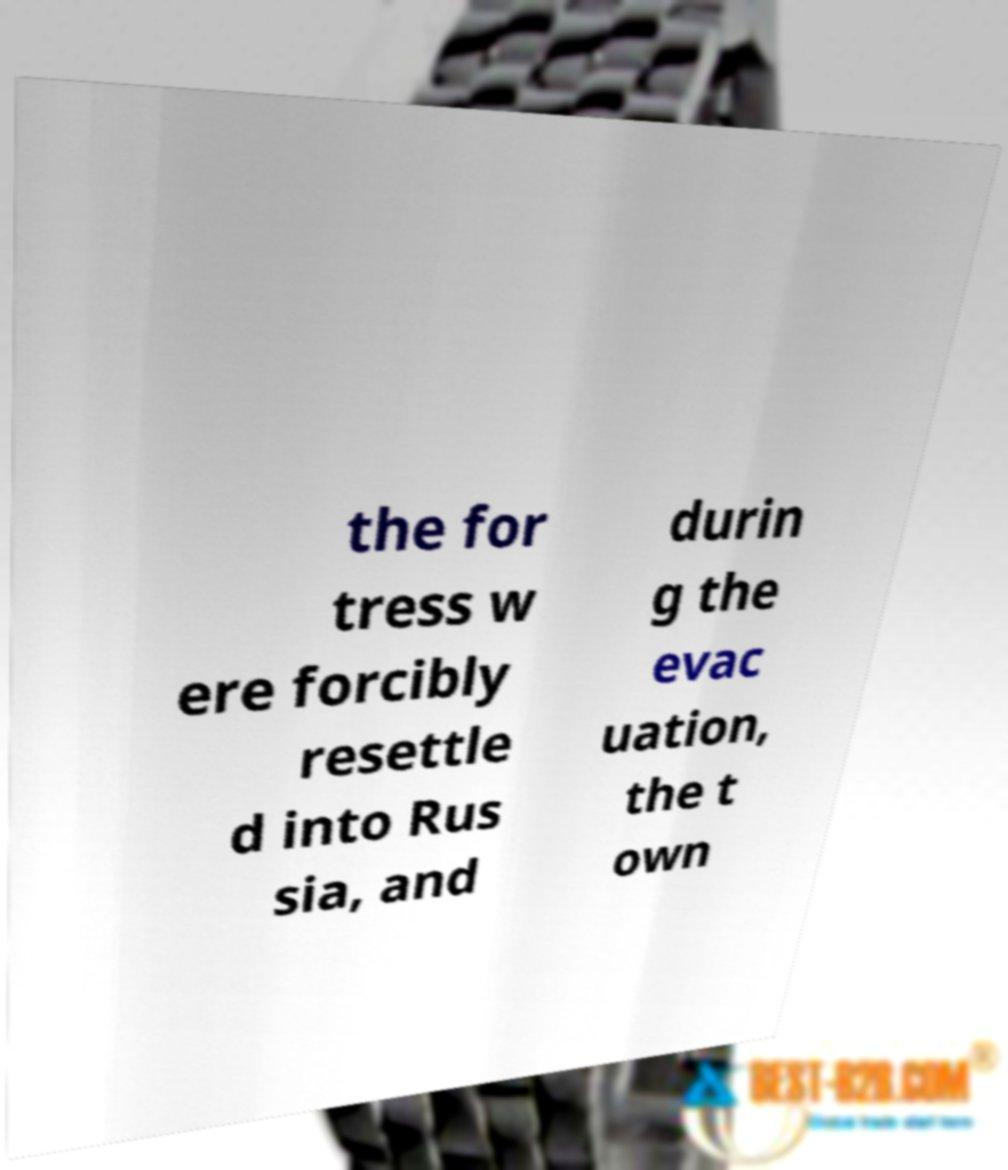Please read and relay the text visible in this image. What does it say? the for tress w ere forcibly resettle d into Rus sia, and durin g the evac uation, the t own 